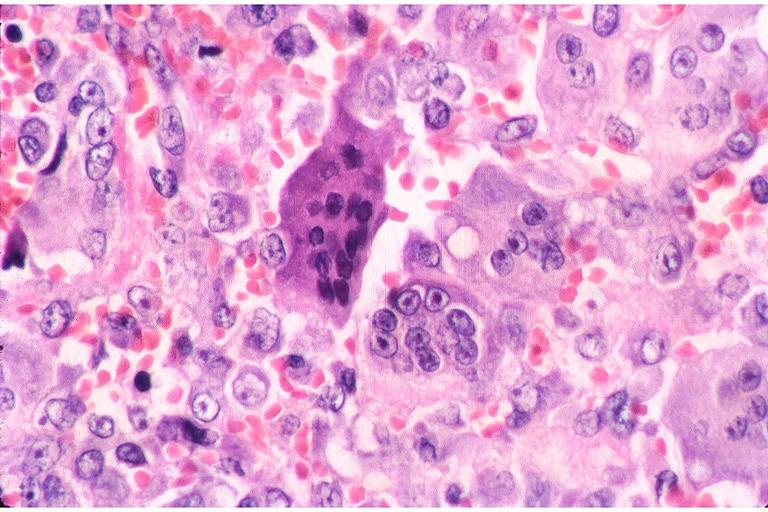what is present?
Answer the question using a single word or phrase. Oral 